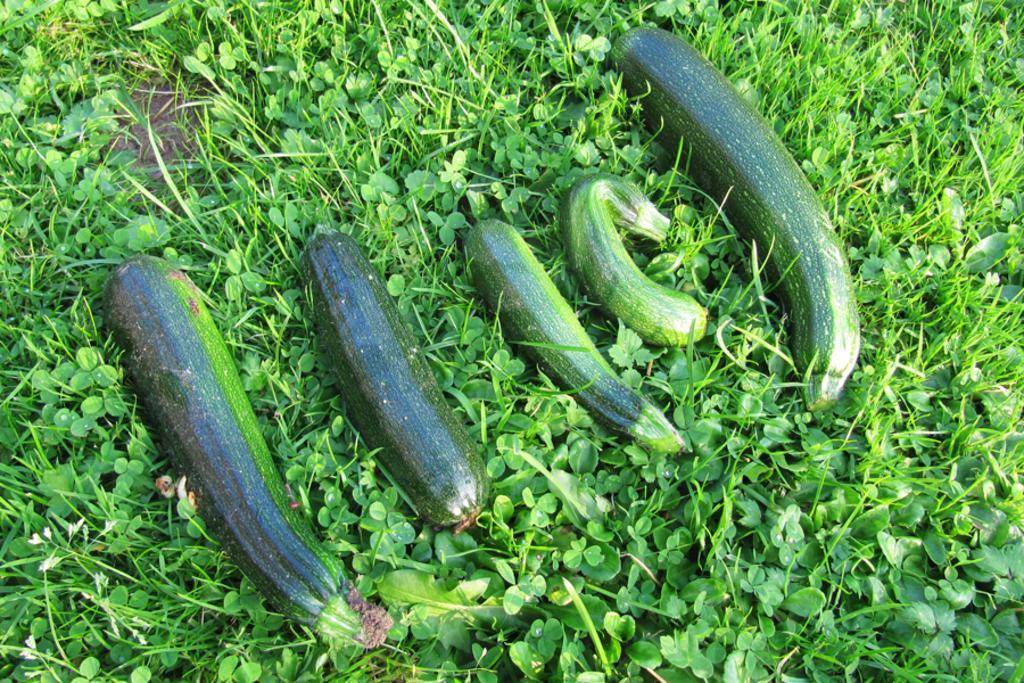Can you describe this image briefly? There are green color vegetables arranged on the grass on the ground. In the background, there are green color color plants. 